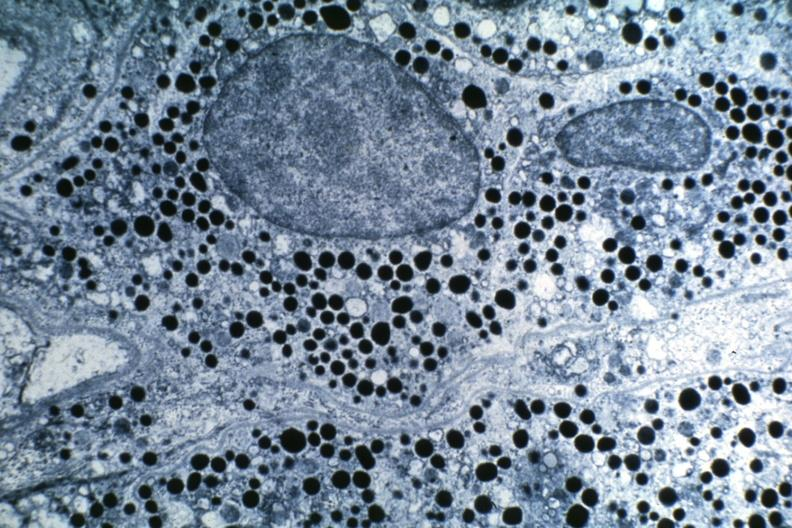what is present?
Answer the question using a single word or phrase. Endocrine 